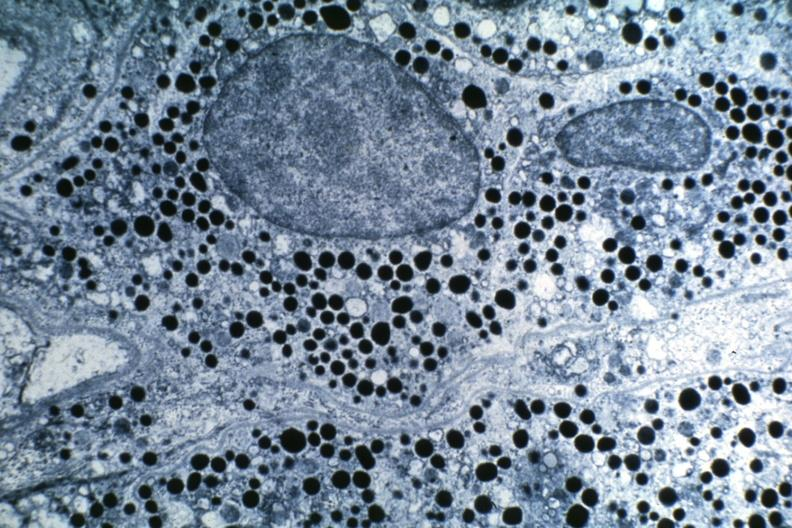what is present?
Answer the question using a single word or phrase. Endocrine 